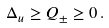<formula> <loc_0><loc_0><loc_500><loc_500>\Delta _ { u } \geq Q _ { \pm } \geq 0 \, .</formula> 